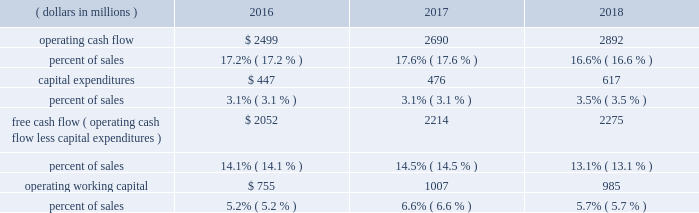24 | 2018 emerson annual report 2017 vs .
2016 2013 commercial & residential solutions sales were $ 5.9 billion in 2017 , an increase of $ 302 million , or 5 percent , reflecting favorable conditions in hvac and refrigeration markets in the u.s. , asia and europe , as well as u.s .
And asian construction markets .
Underlying sales increased 5 percent ( $ 297 million ) on 6 percent higher volume , partially offset by 1 percent lower price .
Foreign currency translation deducted $ 20 million and acquisitions added $ 25 million .
Climate technologies sales were $ 4.2 billion in 2017 , an increase of $ 268 million , or 7 percent .
Global air conditioning sales were solid , led by strength in the u.s .
And asia and robust growth in china partially due to easier comparisons , while sales were up modestly in europe and declined moderately in middle east/africa .
Global refrigeration sales were strong , reflecting robust growth in china on increased adoption of energy- efficient solutions and slight growth in the u.s .
Sensors and solutions had strong growth , while temperature controls was up modestly .
Tools & home products sales were $ 1.6 billion in 2017 , up $ 34 million compared to the prior year .
Professional tools had strong growth on favorable demand from oil and gas customers and in other construction-related markets .
Wet/dry vacuums sales were up moderately as favorable conditions continued in u.s .
Construction markets .
Food waste disposers increased slightly , while the storage business declined moderately .
Overall , underlying sales increased 3 percent in the u.s. , 4 percent in europe and 17 percent in asia ( china up 27 percent ) .
Sales increased 3 percent in latin america and 4 percent in canada , while sales decreased 5 percent in middle east/africa .
Earnings were $ 1.4 billion , an increase of $ 72 million driven by climate technologies , while margin was flat .
Increased volume and resulting leverage , savings from cost reduction actions , and lower customer accommodation costs of $ 16 million were largely offset by higher materials costs , lower price and unfavorable product mix .
Financial position , capital resources and liquidity the company continues to generate substantial cash from operations and has the resources available to reinvest for growth in existing businesses , pursue strategic acquisitions and manage its capital structure on a short- and long-term basis .
Cash flow from continuing operations ( dollars in millions ) 2016 2017 2018 .
Operating cash flow from continuing operations for 2018 was $ 2.9 billion , a $ 202 million , or 8 percent increase compared with 2017 , primarily due to higher earnings , partially offset by an increase in working capital investment to support higher levels of sales activity and income taxes paid on the residential storage divestiture .
Operating cash flow from continuing operations of $ 2.7 billion in 2017 increased 8 percent compared to $ 2.5 billion in 2016 , reflecting higher earnings and favorable changes in working capital .
At september 30 , 2018 , operating working capital as a percent of sales was 5.7 percent compared with 6.6 percent in 2017 and 5.2 percent in 2016 .
The increase in 2017 was due to higher levels of working capital in the acquired valves & controls business .
Operating cash flow from continuing operations funded capital expenditures of $ 617 million , dividends of $ 1.2 billion , and common stock purchases of $ 1.0 billion .
In 2018 , the company repatriated $ 1.4 billion of cash held by non-u.s .
Subsidiaries , which was part of the company 2019s previously announced plans .
These funds along with increased short-term borrowings and divestiture proceeds supported acquisitions of $ 2.2 billion .
Contributions to pension plans were $ 61 million in 2018 , $ 45 million in 2017 and $ 66 million in 2016 .
Capital expenditures related to continuing operations were $ 617 million , $ 476 million and $ 447 million in 2018 , 2017 and 2016 , respectively .
Free cash flow from continuing operations ( operating cash flow less capital expenditures ) was $ 2.3 billion in 2018 , up 3 percent .
Free cash flow was $ 2.2 billion in 2017 , compared with $ 2.1 billion in 2016 .
The company is targeting capital spending of approximately $ 650 million in 2019 .
Net cash paid in connection with acquisitions was $ 2.2 billion , $ 3.0 billion and $ 132 million in 2018 , 2017 and 2016 , respectively .
Proceeds from divestitures not classified as discontinued operations were $ 201 million and $ 39 million in 2018 and 2017 , respectively .
Dividends were $ 1.2 billion ( $ 1.94 per share ) in 2018 , compared with $ 1.2 billion ( $ 1.92 per share ) in 2017 and $ 1.2 billion ( $ 1.90 per share ) in 2016 .
In november 2018 , the board of directors voted to increase the quarterly cash dividend 1 percent , to an annualized rate of $ 1.96 per share .
Purchases of emerson common stock totaled $ 1.0 billion , $ 400 million and $ 601 million in 2018 , 2017 and 2016 , respectively , at average per share prices of $ 66.25 , $ 60.51 and $ 48.11 .
The board of directors authorized the purchase of up to 70 million common shares in november 2015 , and 41.8 million shares remain available for purchase under this authorization .
The company purchased 15.1 million shares in 2018 , 6.6 million shares in 2017 , and 12.5 million shares in 2016 under this authorization and the remainder of the may 2013 authorization. .
What was the change as a percent of sales in operating cash flow between 2016 and 2018? 
Computations: (16.6% - 17.2%)
Answer: -0.006. 